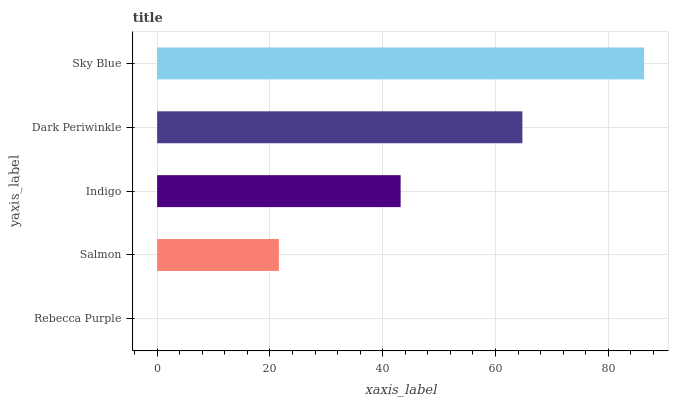Is Rebecca Purple the minimum?
Answer yes or no. Yes. Is Sky Blue the maximum?
Answer yes or no. Yes. Is Salmon the minimum?
Answer yes or no. No. Is Salmon the maximum?
Answer yes or no. No. Is Salmon greater than Rebecca Purple?
Answer yes or no. Yes. Is Rebecca Purple less than Salmon?
Answer yes or no. Yes. Is Rebecca Purple greater than Salmon?
Answer yes or no. No. Is Salmon less than Rebecca Purple?
Answer yes or no. No. Is Indigo the high median?
Answer yes or no. Yes. Is Indigo the low median?
Answer yes or no. Yes. Is Rebecca Purple the high median?
Answer yes or no. No. Is Sky Blue the low median?
Answer yes or no. No. 